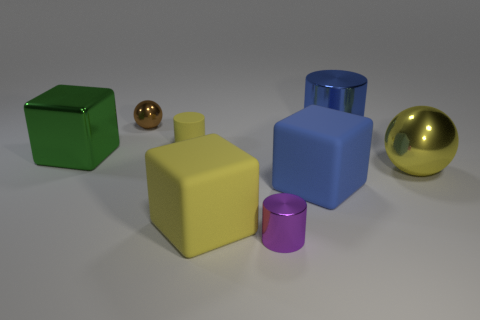There is a blue block; is its size the same as the blue thing behind the green metal block?
Provide a succinct answer. Yes. What number of spheres are either brown metallic objects or big yellow things?
Give a very brief answer. 2. How many large things are both on the left side of the big cylinder and behind the big yellow rubber block?
Provide a short and direct response. 2. How many other objects are there of the same color as the large metallic cylinder?
Offer a terse response. 1. What is the shape of the tiny thing in front of the blue matte object?
Ensure brevity in your answer.  Cylinder. Do the yellow cylinder and the large yellow ball have the same material?
Your answer should be compact. No. There is a small purple metal object; what number of cylinders are on the left side of it?
Offer a terse response. 1. The small shiny thing in front of the tiny metallic object that is behind the yellow block is what shape?
Provide a succinct answer. Cylinder. Are there more large spheres left of the tiny brown shiny sphere than big metal cubes?
Give a very brief answer. No. There is a cylinder that is in front of the rubber cylinder; how many blue metallic cylinders are in front of it?
Your answer should be compact. 0. 